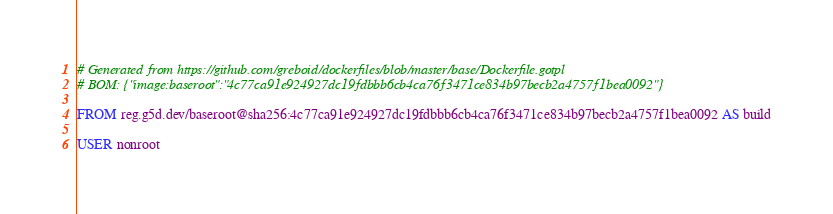<code> <loc_0><loc_0><loc_500><loc_500><_Dockerfile_># Generated from https://github.com/greboid/dockerfiles/blob/master/base/Dockerfile.gotpl
# BOM: {"image:baseroot":"4c77ca91e924927dc19fdbbb6cb4ca76f3471ce834b97becb2a4757f1bea0092"}

FROM reg.g5d.dev/baseroot@sha256:4c77ca91e924927dc19fdbbb6cb4ca76f3471ce834b97becb2a4757f1bea0092 AS build

USER nonroot
</code> 